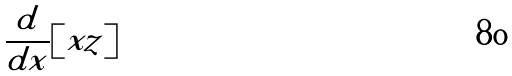Convert formula to latex. <formula><loc_0><loc_0><loc_500><loc_500>\frac { d } { d x } [ x z ]</formula> 